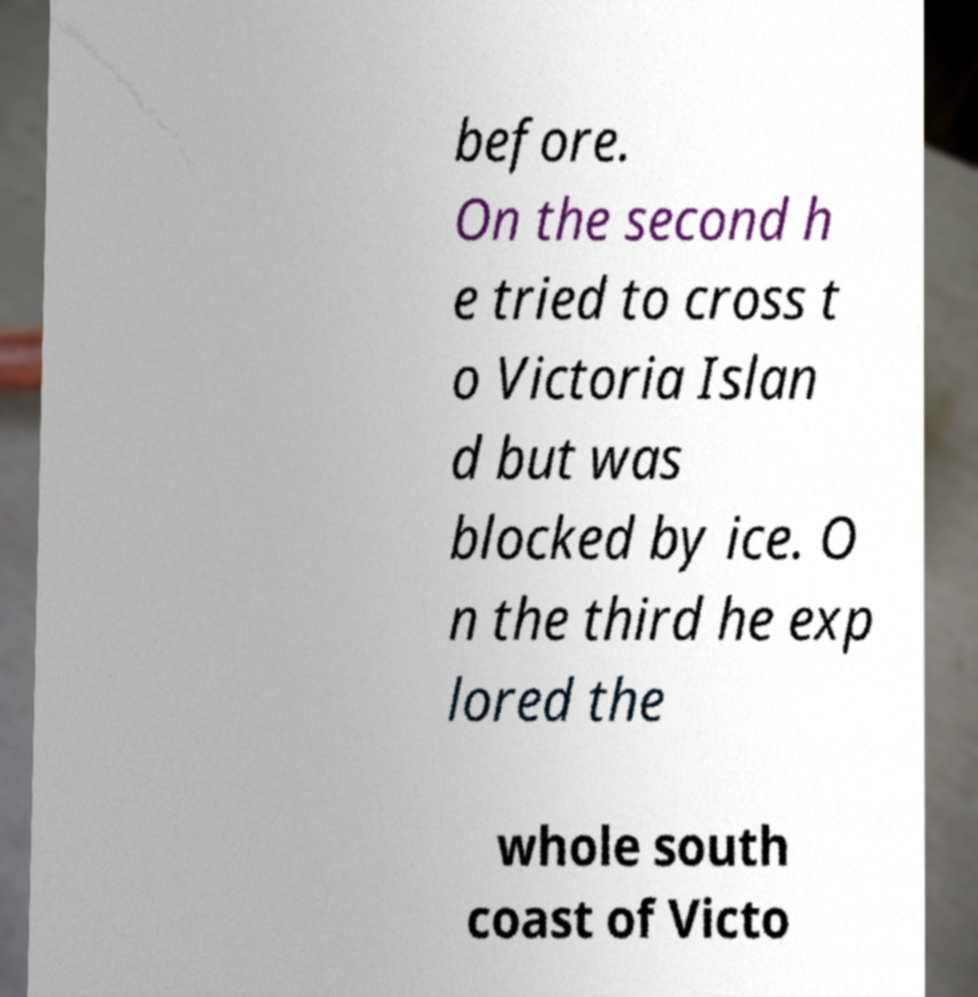I need the written content from this picture converted into text. Can you do that? before. On the second h e tried to cross t o Victoria Islan d but was blocked by ice. O n the third he exp lored the whole south coast of Victo 